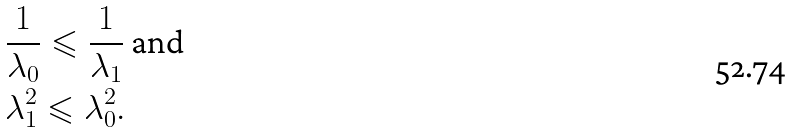<formula> <loc_0><loc_0><loc_500><loc_500>& \frac { 1 } { \lambda _ { 0 } } \leqslant \frac { 1 } { \lambda _ { 1 } } \text { and } \\ & \lambda _ { 1 } ^ { 2 } \leqslant \lambda _ { 0 } ^ { 2 } .</formula> 